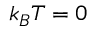Convert formula to latex. <formula><loc_0><loc_0><loc_500><loc_500>k _ { B } T = 0</formula> 